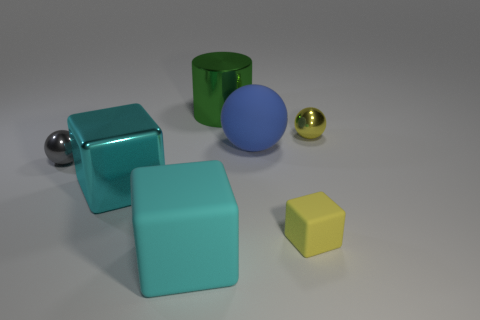Does the small block have the same material as the gray object?
Make the answer very short. No. How many purple objects are small rubber things or large metallic objects?
Your response must be concise. 0. Are there more small yellow metallic spheres on the right side of the small cube than large purple spheres?
Give a very brief answer. Yes. Are there any small metal things that have the same color as the small rubber object?
Provide a succinct answer. Yes. What is the size of the green object?
Provide a succinct answer. Large. Is the color of the metallic block the same as the big rubber block?
Keep it short and to the point. Yes. What number of things are blue rubber things or things that are behind the gray thing?
Your response must be concise. 3. How many yellow matte things are on the left side of the large cyan matte cube that is left of the metal sphere that is right of the large cyan metallic thing?
Make the answer very short. 0. There is another big cube that is the same color as the metal block; what material is it?
Make the answer very short. Rubber. How many large gray matte blocks are there?
Offer a very short reply. 0. 